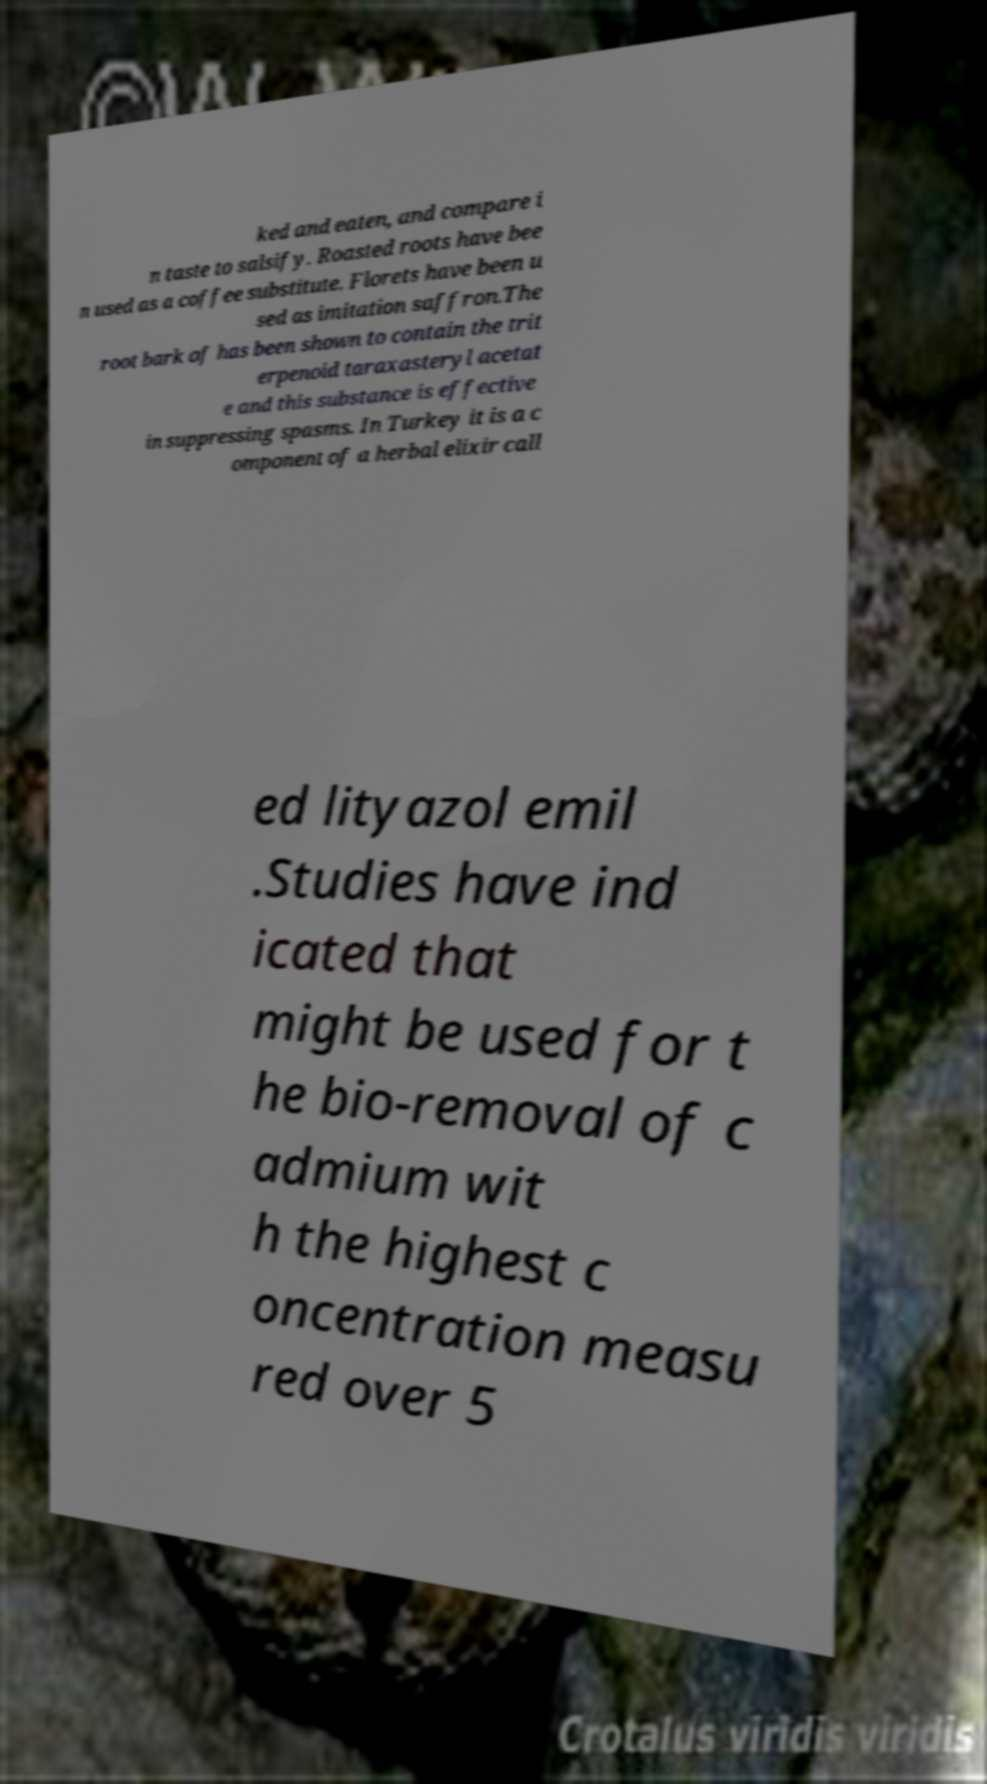Could you assist in decoding the text presented in this image and type it out clearly? ked and eaten, and compare i n taste to salsify. Roasted roots have bee n used as a coffee substitute. Florets have been u sed as imitation saffron.The root bark of has been shown to contain the trit erpenoid taraxasteryl acetat e and this substance is effective in suppressing spasms. In Turkey it is a c omponent of a herbal elixir call ed lityazol emil .Studies have ind icated that might be used for t he bio-removal of c admium wit h the highest c oncentration measu red over 5 